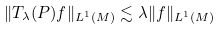Convert formula to latex. <formula><loc_0><loc_0><loc_500><loc_500>\| T _ { \lambda } ( P ) f \| _ { L ^ { 1 } ( M ) } \lesssim \lambda \| f \| _ { L ^ { 1 } ( M ) }</formula> 